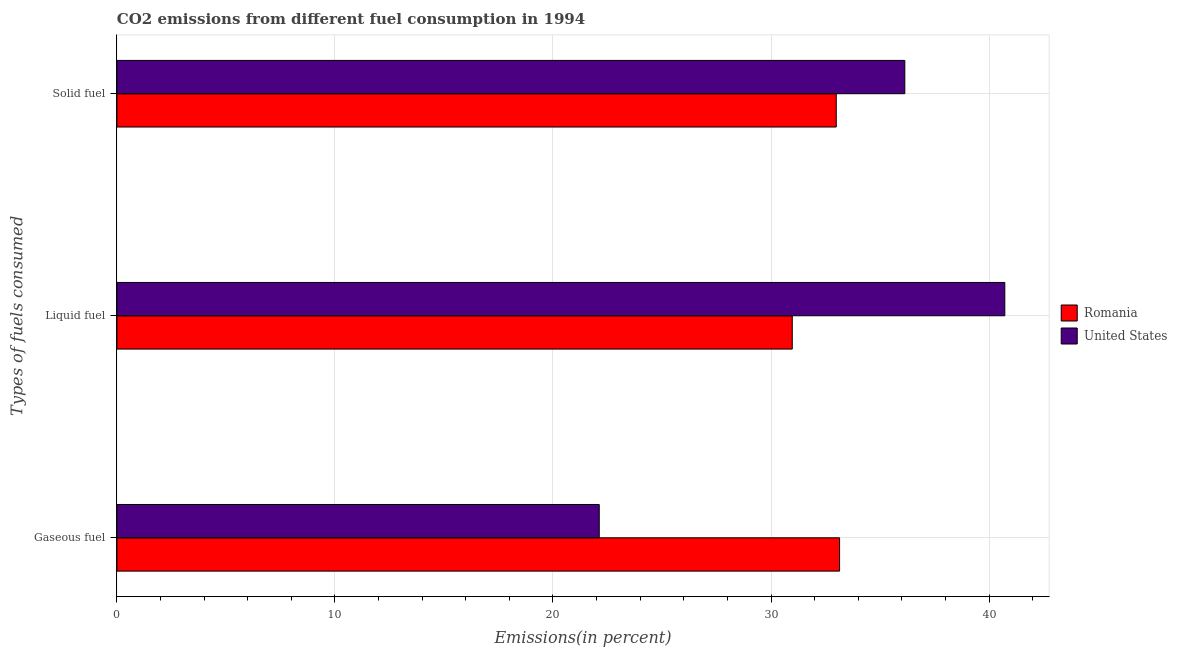Are the number of bars per tick equal to the number of legend labels?
Give a very brief answer. Yes. Are the number of bars on each tick of the Y-axis equal?
Your answer should be very brief. Yes. How many bars are there on the 3rd tick from the top?
Provide a short and direct response. 2. How many bars are there on the 3rd tick from the bottom?
Ensure brevity in your answer.  2. What is the label of the 1st group of bars from the top?
Provide a short and direct response. Solid fuel. What is the percentage of solid fuel emission in Romania?
Offer a very short reply. 32.99. Across all countries, what is the maximum percentage of gaseous fuel emission?
Provide a short and direct response. 33.14. Across all countries, what is the minimum percentage of solid fuel emission?
Provide a succinct answer. 32.99. In which country was the percentage of gaseous fuel emission maximum?
Provide a succinct answer. Romania. In which country was the percentage of solid fuel emission minimum?
Provide a succinct answer. Romania. What is the total percentage of solid fuel emission in the graph?
Your answer should be very brief. 69.13. What is the difference between the percentage of solid fuel emission in Romania and that in United States?
Provide a succinct answer. -3.14. What is the difference between the percentage of solid fuel emission in United States and the percentage of liquid fuel emission in Romania?
Your answer should be very brief. 5.16. What is the average percentage of liquid fuel emission per country?
Offer a terse response. 35.85. What is the difference between the percentage of gaseous fuel emission and percentage of liquid fuel emission in Romania?
Give a very brief answer. 2.17. What is the ratio of the percentage of gaseous fuel emission in United States to that in Romania?
Your response must be concise. 0.67. Is the difference between the percentage of liquid fuel emission in United States and Romania greater than the difference between the percentage of gaseous fuel emission in United States and Romania?
Your response must be concise. Yes. What is the difference between the highest and the second highest percentage of liquid fuel emission?
Offer a terse response. 9.75. What is the difference between the highest and the lowest percentage of gaseous fuel emission?
Keep it short and to the point. 11.02. Is the sum of the percentage of gaseous fuel emission in Romania and United States greater than the maximum percentage of liquid fuel emission across all countries?
Give a very brief answer. Yes. What is the difference between two consecutive major ticks on the X-axis?
Make the answer very short. 10. Where does the legend appear in the graph?
Give a very brief answer. Center right. How many legend labels are there?
Your response must be concise. 2. What is the title of the graph?
Ensure brevity in your answer.  CO2 emissions from different fuel consumption in 1994. Does "Vietnam" appear as one of the legend labels in the graph?
Make the answer very short. No. What is the label or title of the X-axis?
Keep it short and to the point. Emissions(in percent). What is the label or title of the Y-axis?
Your answer should be very brief. Types of fuels consumed. What is the Emissions(in percent) of Romania in Gaseous fuel?
Provide a short and direct response. 33.14. What is the Emissions(in percent) of United States in Gaseous fuel?
Your answer should be very brief. 22.12. What is the Emissions(in percent) in Romania in Liquid fuel?
Keep it short and to the point. 30.97. What is the Emissions(in percent) of United States in Liquid fuel?
Your answer should be very brief. 40.72. What is the Emissions(in percent) of Romania in Solid fuel?
Offer a very short reply. 32.99. What is the Emissions(in percent) in United States in Solid fuel?
Your response must be concise. 36.14. Across all Types of fuels consumed, what is the maximum Emissions(in percent) of Romania?
Give a very brief answer. 33.14. Across all Types of fuels consumed, what is the maximum Emissions(in percent) in United States?
Provide a succinct answer. 40.72. Across all Types of fuels consumed, what is the minimum Emissions(in percent) of Romania?
Keep it short and to the point. 30.97. Across all Types of fuels consumed, what is the minimum Emissions(in percent) in United States?
Give a very brief answer. 22.12. What is the total Emissions(in percent) in Romania in the graph?
Make the answer very short. 97.11. What is the total Emissions(in percent) in United States in the graph?
Make the answer very short. 98.98. What is the difference between the Emissions(in percent) in Romania in Gaseous fuel and that in Liquid fuel?
Offer a very short reply. 2.17. What is the difference between the Emissions(in percent) of United States in Gaseous fuel and that in Liquid fuel?
Keep it short and to the point. -18.6. What is the difference between the Emissions(in percent) in Romania in Gaseous fuel and that in Solid fuel?
Your answer should be very brief. 0.15. What is the difference between the Emissions(in percent) in United States in Gaseous fuel and that in Solid fuel?
Provide a short and direct response. -14.01. What is the difference between the Emissions(in percent) in Romania in Liquid fuel and that in Solid fuel?
Your answer should be compact. -2.02. What is the difference between the Emissions(in percent) in United States in Liquid fuel and that in Solid fuel?
Make the answer very short. 4.59. What is the difference between the Emissions(in percent) of Romania in Gaseous fuel and the Emissions(in percent) of United States in Liquid fuel?
Your response must be concise. -7.58. What is the difference between the Emissions(in percent) of Romania in Gaseous fuel and the Emissions(in percent) of United States in Solid fuel?
Your answer should be compact. -2.99. What is the difference between the Emissions(in percent) of Romania in Liquid fuel and the Emissions(in percent) of United States in Solid fuel?
Your response must be concise. -5.16. What is the average Emissions(in percent) in Romania per Types of fuels consumed?
Offer a terse response. 32.37. What is the average Emissions(in percent) of United States per Types of fuels consumed?
Ensure brevity in your answer.  32.99. What is the difference between the Emissions(in percent) of Romania and Emissions(in percent) of United States in Gaseous fuel?
Your answer should be very brief. 11.02. What is the difference between the Emissions(in percent) in Romania and Emissions(in percent) in United States in Liquid fuel?
Your answer should be very brief. -9.75. What is the difference between the Emissions(in percent) in Romania and Emissions(in percent) in United States in Solid fuel?
Ensure brevity in your answer.  -3.14. What is the ratio of the Emissions(in percent) of Romania in Gaseous fuel to that in Liquid fuel?
Your answer should be very brief. 1.07. What is the ratio of the Emissions(in percent) in United States in Gaseous fuel to that in Liquid fuel?
Your answer should be very brief. 0.54. What is the ratio of the Emissions(in percent) of Romania in Gaseous fuel to that in Solid fuel?
Keep it short and to the point. 1. What is the ratio of the Emissions(in percent) in United States in Gaseous fuel to that in Solid fuel?
Offer a terse response. 0.61. What is the ratio of the Emissions(in percent) of Romania in Liquid fuel to that in Solid fuel?
Your answer should be very brief. 0.94. What is the ratio of the Emissions(in percent) in United States in Liquid fuel to that in Solid fuel?
Make the answer very short. 1.13. What is the difference between the highest and the second highest Emissions(in percent) in Romania?
Offer a terse response. 0.15. What is the difference between the highest and the second highest Emissions(in percent) of United States?
Provide a short and direct response. 4.59. What is the difference between the highest and the lowest Emissions(in percent) in Romania?
Offer a terse response. 2.17. What is the difference between the highest and the lowest Emissions(in percent) in United States?
Offer a very short reply. 18.6. 